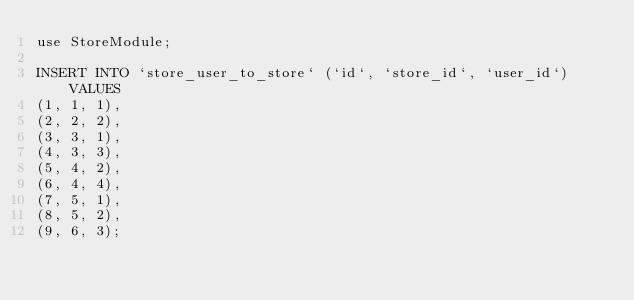Convert code to text. <code><loc_0><loc_0><loc_500><loc_500><_SQL_>use StoreModule;

INSERT INTO `store_user_to_store` (`id`, `store_id`, `user_id`) VALUES
(1, 1, 1),
(2, 2, 2),
(3, 3, 1),
(4, 3, 3),
(5, 4, 2),
(6, 4, 4),
(7, 5, 1),
(8, 5, 2),
(9, 6, 3);
</code> 